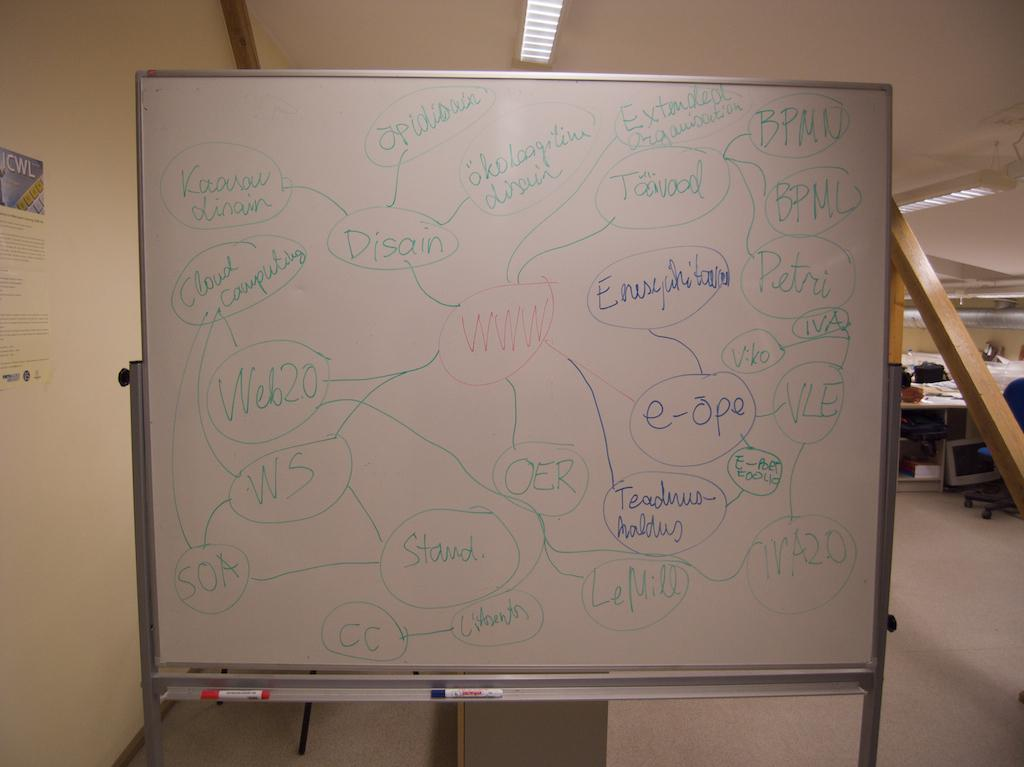<image>
Describe the image concisely. a white board with the red word WWW circled in the middle 